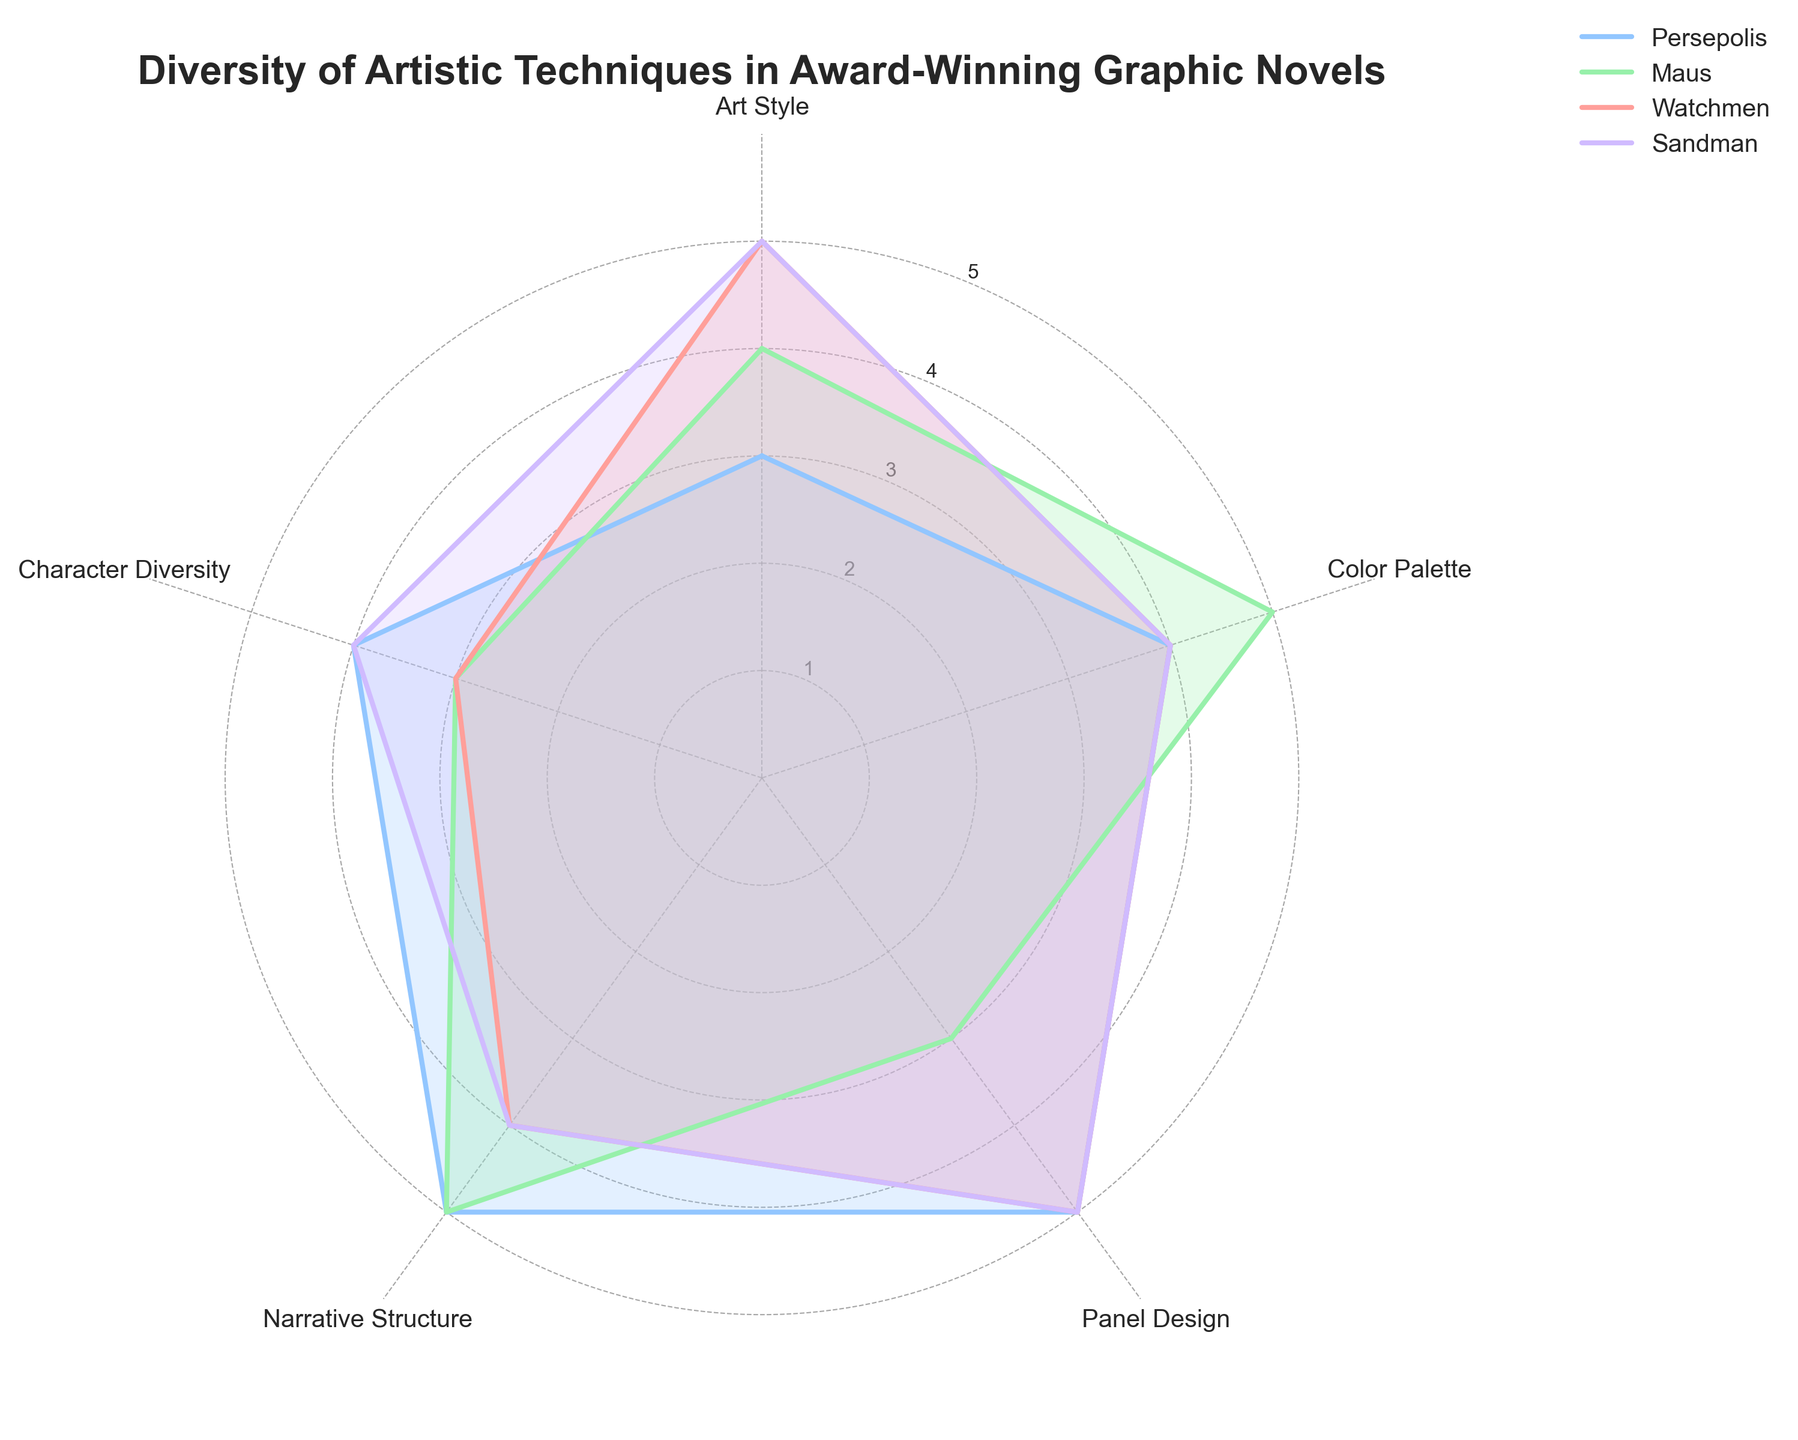what's the title of the figure? The title of the figure is displayed at the top, in bold and larger font size.
Answer: Diversity of Artistic Techniques in Award-Winning Graphic Novels how many variables are plotted on the radar chart? The radar chart has five axes, each representing one of the five categories of artistic techniques.
Answer: 5 which graphic novel has the highest score in "Art Style"? For "Art Style," compare the values for each graphic novel. Watchmen and Sandman have the highest score of 5.
Answer: Watchmen and Sandman which category has the lowest score for "Maus"? Examine the axes for "Maus" and identify the lowest value. The lowest score is 3 for "Character Diversity” and "Panel Design”.
Answer: Character Diversity and Panel Design what's the difference in "Narrative Structure" scores between "Persepolis" and "Watchmen"? Subtract the "Narrative Structure" score of Persepolis from that of Watchmen. Both have a score of 5, so the difference is 0.
Answer: 0 which category shows the most consistent scores across all graphic novels? Compare the scores for each category across all four graphic novels. "Narrative Structure" shows high scores (mostly 4 or 5) for all novels.
Answer: Narrative Structure what's the average score of "Color Palette" across all graphic novels? Add the scores of "Color Palette" for all graphic novels and divide by the number of novels: (4 + 5 + 4 + 4) / 4 = 4.25.
Answer: 4.25 which graphic novel has the most balanced distribution of scores across all categories? Observe the radar chart for each novel and look for one with minimal deviation from the center point for each category. Persepolis is the most balanced, with scores from 3 to 5.
Answer: Persepolis which two graphic novels have the most similar profiles on the radar chart? Compare the shapes of the plots for each pair of graphic novels. Sandman and Watchmen have the most similar profiles.
Answer: Sandman and Watchmen 